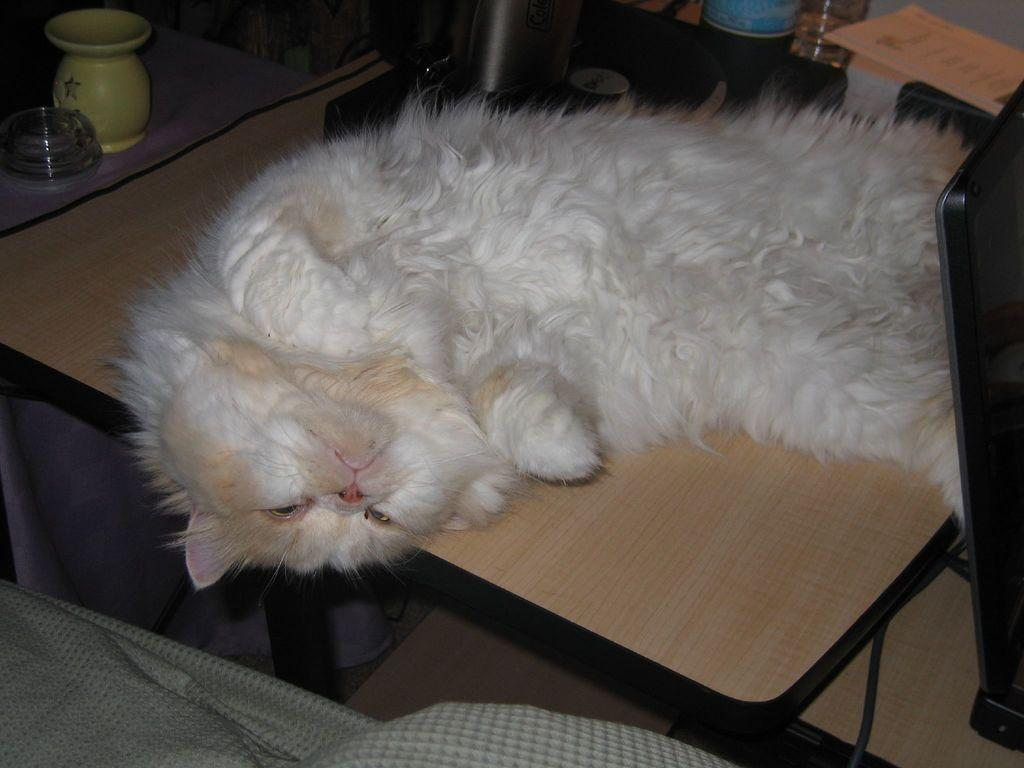What animal can be seen on the table in the image? There is a cat on a table in the image. What type of objects are present in the image besides the cat? There are bottles, papers, and bowls in the image. What is located beside the table in the image? There is a cloth beside the table in the image. What type of mitten is the cat wearing in the image? There is no mitten present in the image, and the cat is not wearing any clothing. Can you describe the neck of the cat in the image? The image does not provide enough detail to describe the cat's neck. 